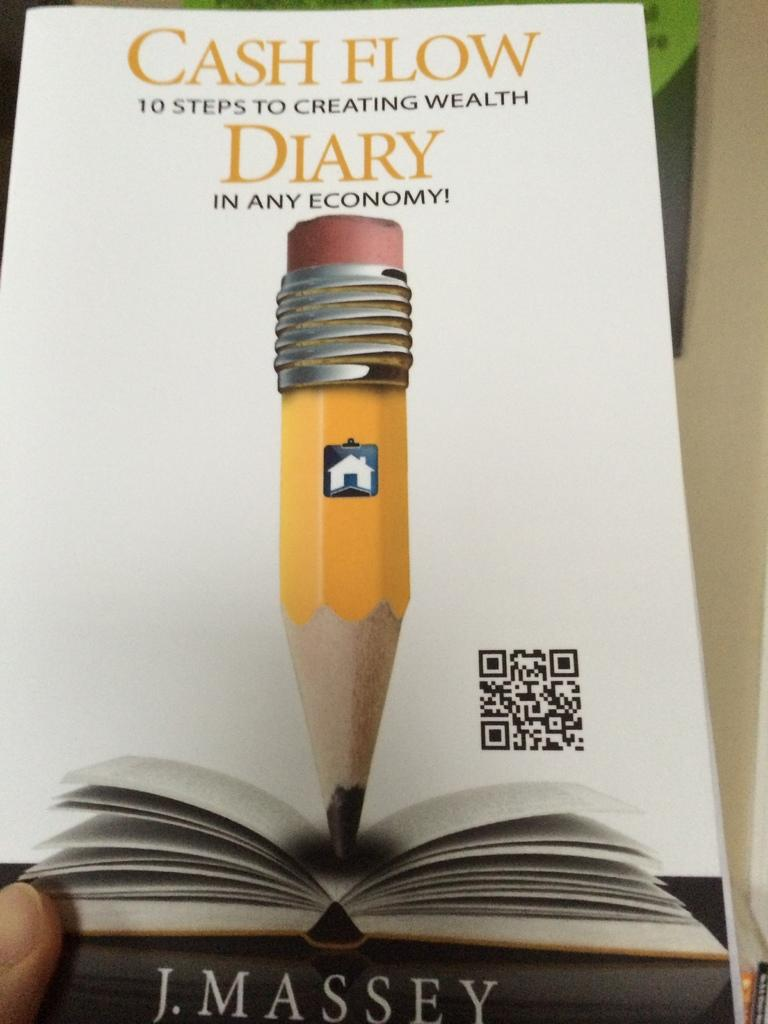<image>
Create a compact narrative representing the image presented. J. Massey has written a book about 10 steps to creating wealth. 